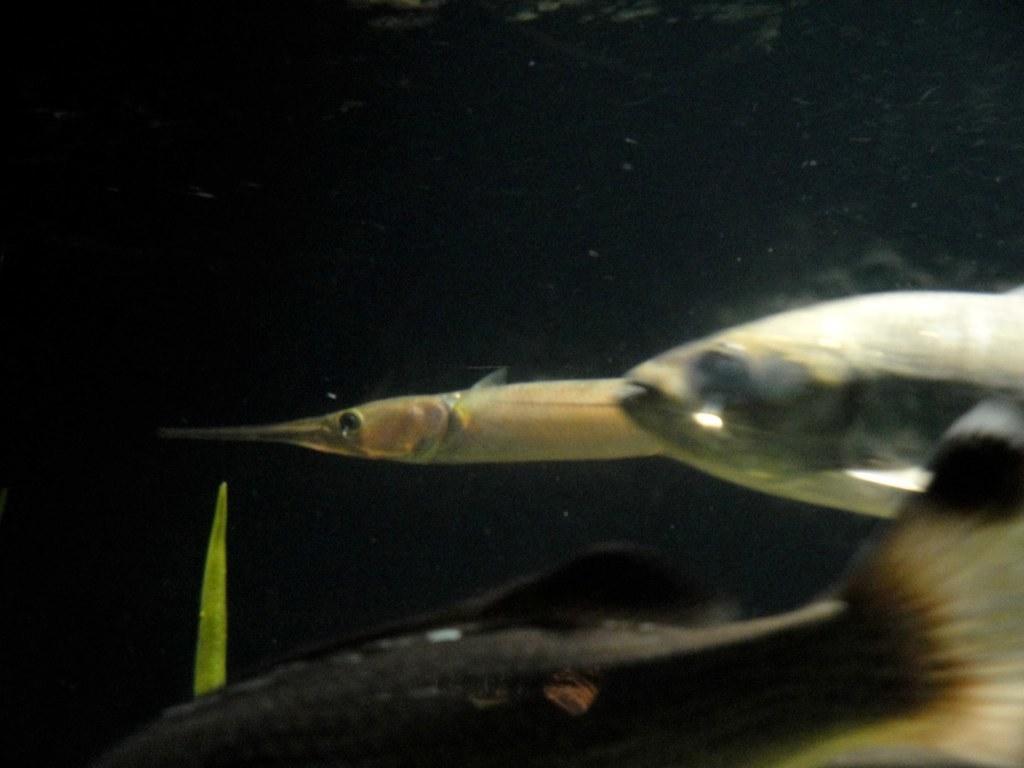Describe this image in one or two sentences. In this picture, we see two fishes are swimming in the water. At the bottom, we see a black fish is swimming in the water. In the background, it is black in color and this picture might be clicked in the aquarium. This picture might be clicked in the dark. 